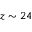Convert formula to latex. <formula><loc_0><loc_0><loc_500><loc_500>z \sim 2 4</formula> 